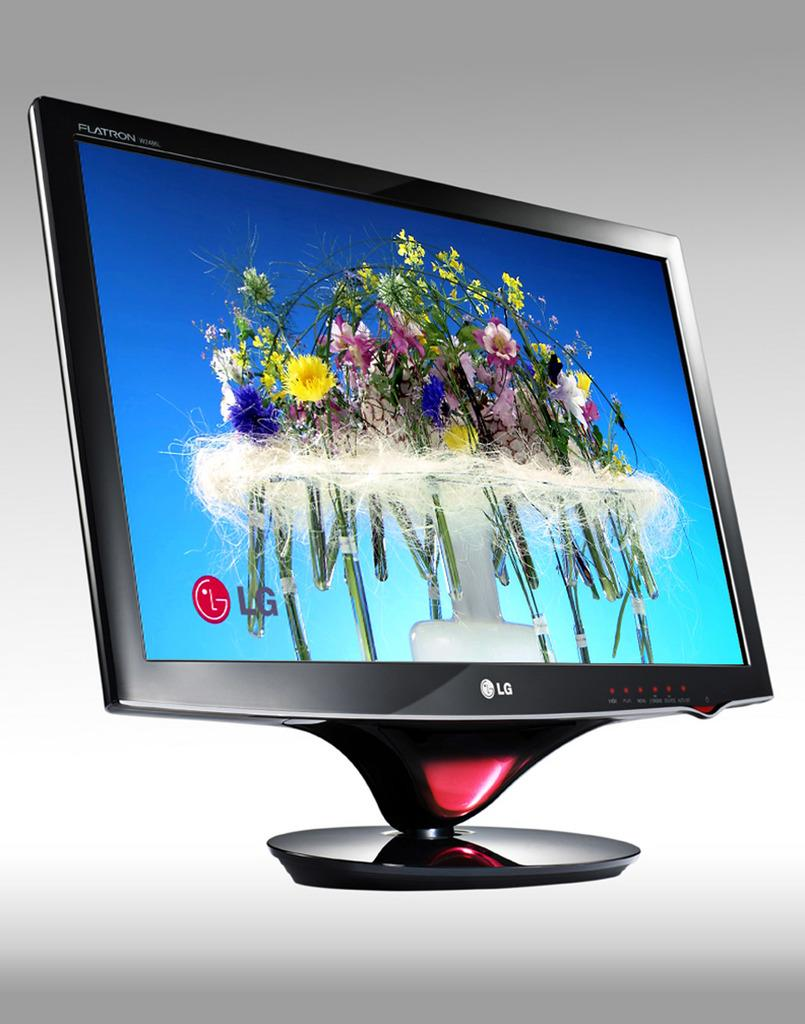What is the main object in the image? There is a television in the image. What is shown on the television screen? The television screen displays flowers and water. Can you identify any other elements on the screen? The company logo is visible at the bottom of the screen. What type of juice can be seen being poured on the street in the image? There is no juice or street present in the image; it features a television displaying flowers and water. 